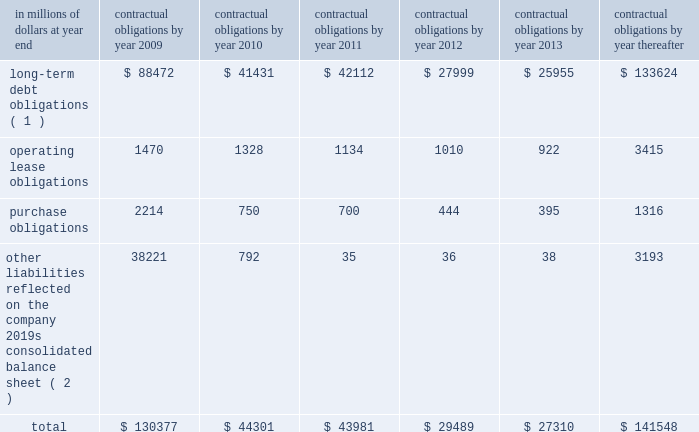Contractual obligations the table includes aggregated information about citigroup 2019s contractual obligations that impact its short- and long-term liquidity and capital needs .
The table includes information about payments due under specified contractual obligations , aggregated by type of contractual obligation .
It includes the maturity profile of the company 2019s consolidated long-term debt , operating leases and other long-term liabilities .
The company 2019s capital lease obligations are included in purchase obligations in the table .
Citigroup 2019s contractual obligations include purchase obligations that are enforceable and legally binding for the company .
For the purposes of the table below , purchase obligations are included through the termination date of the respective agreements , even if the contract is renewable .
Many of the purchase agreements for goods or services include clauses that would allow the company to cancel the agreement with specified notice ; however , that impact is not included in the table ( unless citigroup has already notified the counterparty of its intention to terminate the agreement ) .
Other liabilities reflected on the company 2019s consolidated balance sheet include obligations for goods and services that have already been received , litigation settlements , uncertain tax positions , as well as other long-term liabilities that have been incurred and will ultimately be paid in cash .
Excluded from the table are obligations that are generally short term in nature , including deposit liabilities and securities sold under agreements to repurchase .
The table also excludes certain insurance and investment contracts subject to mortality and morbidity risks or without defined maturities , such that the timing of payments and withdrawals is uncertain .
The liabilities related to these insurance and investment contracts are included on the consolidated balance sheet as insurance policy and claims reserves , contractholder funds , and separate and variable accounts .
Citigroup 2019s funding policy for pension plans is generally to fund to the minimum amounts required by the applicable laws and regulations .
At december 31 , 2008 , there were no minimum required contributions , and no contributions are currently planned for the u.s .
Pension plans .
Accordingly , no amounts have been included in the table below for future contributions to the u.s .
Pension plans .
For the non-u.s .
Plans , discretionary contributions in 2009 are anticipated to be approximately $ 167 million and this amount has been included in purchase obligations in the table below .
The estimated pension plan contributions are subject to change , since contribution decisions are affected by various factors , such as market performance , regulatory and legal requirements , and management 2019s ability to change funding policy .
For additional information regarding the company 2019s retirement benefit obligations , see note 9 to the consolidated financial statements on page 144. .
( 1 ) for additional information about long-term debt and trust preferred securities , see note 20 to the consolidated financial statements on page 169 .
( 2 ) relates primarily to accounts payable and accrued expenses included in other liabilities in the company 2019s consolidated balance sheet .
Also included are various litigation settlements. .
What was the percentage increase in the operating lease obligations from 2009 to 2010? 
Computations: ((1470 - 1328) / 1328)
Answer: 0.10693. 